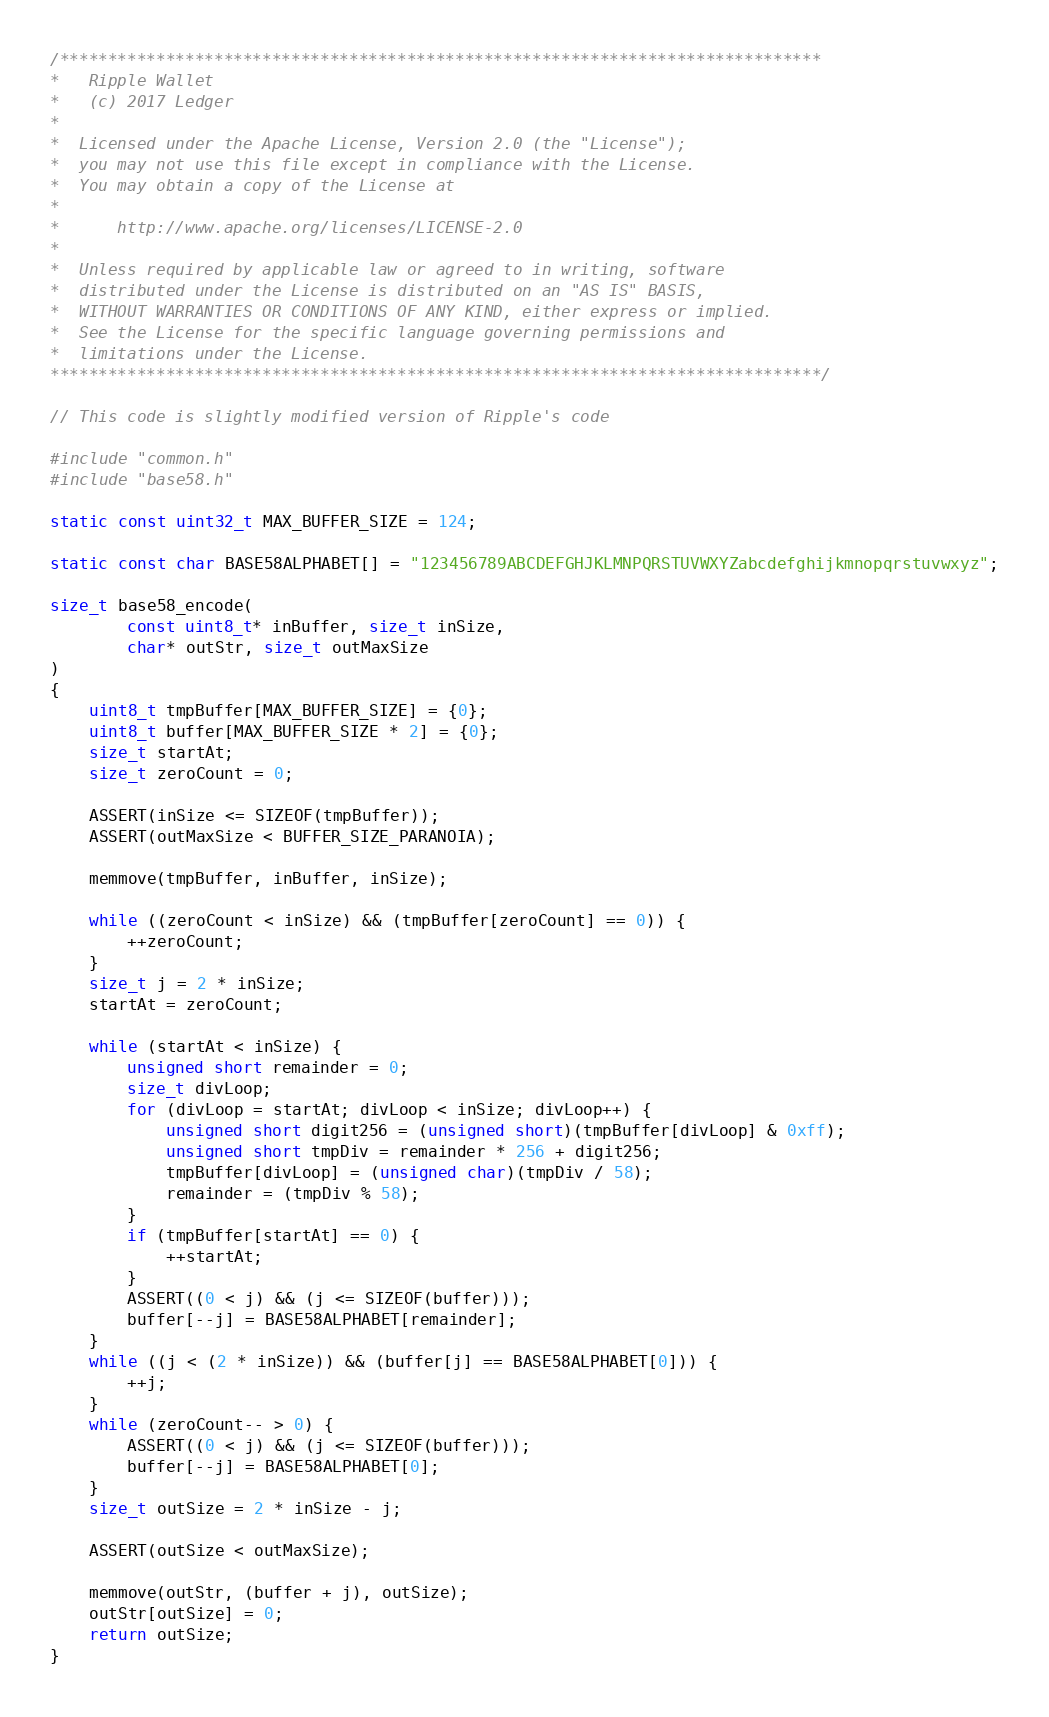Convert code to text. <code><loc_0><loc_0><loc_500><loc_500><_C_>/*******************************************************************************
*   Ripple Wallet
*   (c) 2017 Ledger
*
*  Licensed under the Apache License, Version 2.0 (the "License");
*  you may not use this file except in compliance with the License.
*  You may obtain a copy of the License at
*
*      http://www.apache.org/licenses/LICENSE-2.0
*
*  Unless required by applicable law or agreed to in writing, software
*  distributed under the License is distributed on an "AS IS" BASIS,
*  WITHOUT WARRANTIES OR CONDITIONS OF ANY KIND, either express or implied.
*  See the License for the specific language governing permissions and
*  limitations under the License.
********************************************************************************/

// This code is slightly modified version of Ripple's code

#include "common.h"
#include "base58.h"

static const uint32_t MAX_BUFFER_SIZE = 124;

static const char BASE58ALPHABET[] = "123456789ABCDEFGHJKLMNPQRSTUVWXYZabcdefghijkmnopqrstuvwxyz";

size_t base58_encode(
        const uint8_t* inBuffer, size_t inSize,
        char* outStr, size_t outMaxSize
)
{
	uint8_t tmpBuffer[MAX_BUFFER_SIZE] = {0};
	uint8_t buffer[MAX_BUFFER_SIZE * 2] = {0};
	size_t startAt;
	size_t zeroCount = 0;

	ASSERT(inSize <= SIZEOF(tmpBuffer));
	ASSERT(outMaxSize < BUFFER_SIZE_PARANOIA);

	memmove(tmpBuffer, inBuffer, inSize);

	while ((zeroCount < inSize) && (tmpBuffer[zeroCount] == 0)) {
		++zeroCount;
	}
	size_t j = 2 * inSize;
	startAt = zeroCount;

	while (startAt < inSize) {
		unsigned short remainder = 0;
		size_t divLoop;
		for (divLoop = startAt; divLoop < inSize; divLoop++) {
			unsigned short digit256 = (unsigned short)(tmpBuffer[divLoop] & 0xff);
			unsigned short tmpDiv = remainder * 256 + digit256;
			tmpBuffer[divLoop] = (unsigned char)(tmpDiv / 58);
			remainder = (tmpDiv % 58);
		}
		if (tmpBuffer[startAt] == 0) {
			++startAt;
		}
		ASSERT((0 < j) && (j <= SIZEOF(buffer)));
		buffer[--j] = BASE58ALPHABET[remainder];
	}
	while ((j < (2 * inSize)) && (buffer[j] == BASE58ALPHABET[0])) {
		++j;
	}
	while (zeroCount-- > 0) {
		ASSERT((0 < j) && (j <= SIZEOF(buffer)));
		buffer[--j] = BASE58ALPHABET[0];
	}
	size_t outSize = 2 * inSize - j;

	ASSERT(outSize < outMaxSize);

	memmove(outStr, (buffer + j), outSize);
	outStr[outSize] = 0;
	return outSize;
}
</code> 